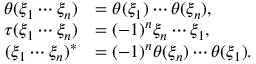<formula> <loc_0><loc_0><loc_500><loc_500>\begin{array} { r l } { \theta ( \xi _ { 1 } \cdots \xi _ { n } ) } & { = \theta ( \xi _ { 1 } ) \cdots \theta ( \xi _ { n } ) , } \\ { \tau ( \xi _ { 1 } \cdots \xi _ { n } ) } & { = ( - 1 ) ^ { n } \xi _ { n } \cdots \xi _ { 1 } , } \\ { ( \xi _ { 1 } \cdots \xi _ { n } ) ^ { \ast } } & { = ( - 1 ) ^ { n } \theta ( \xi _ { n } ) \cdots \theta ( \xi _ { 1 } ) . } \end{array}</formula> 